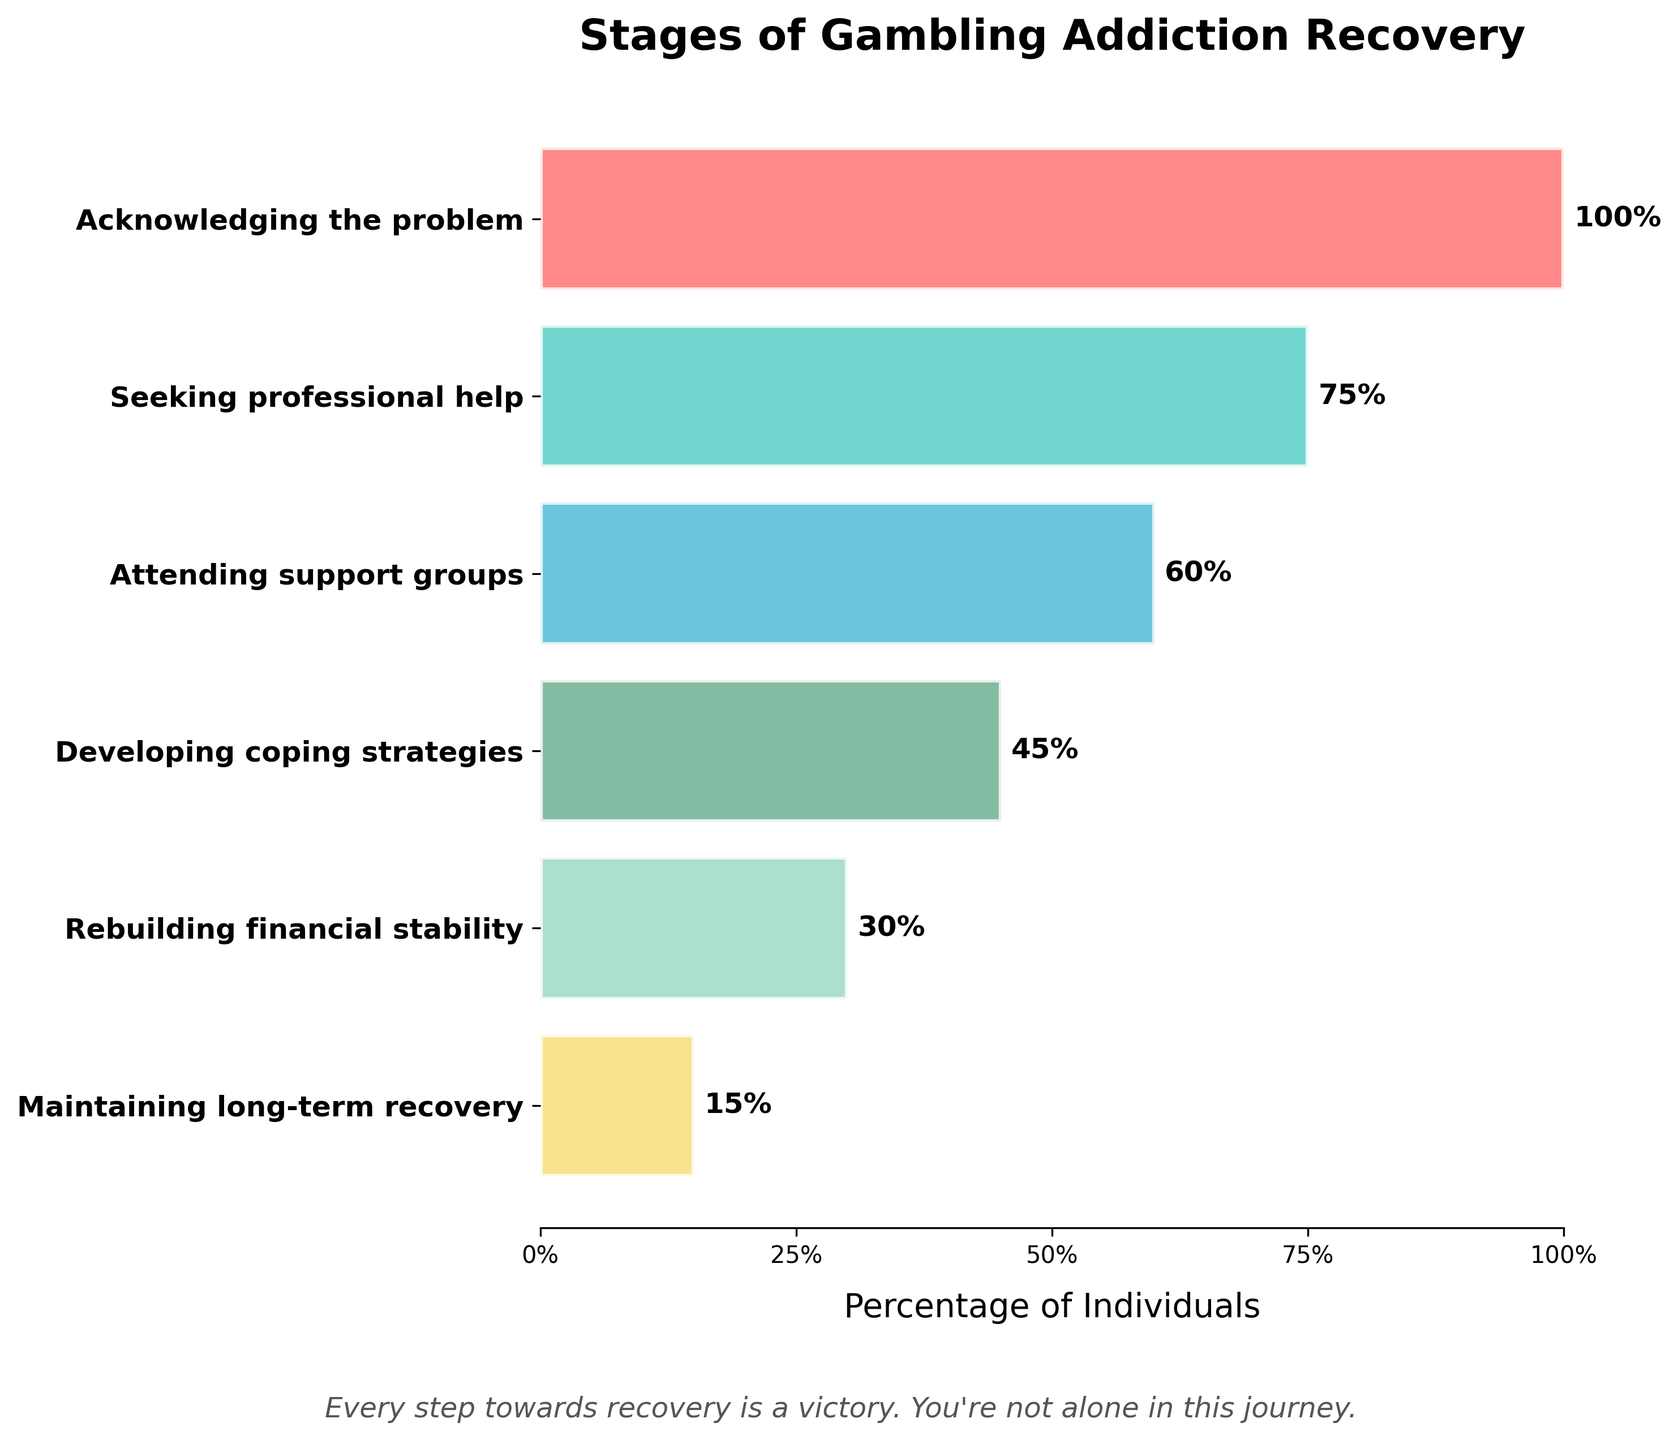What is the title of the funnel chart? The title is written at the top of the chart, above the graphical elements.
Answer: "Stages of Gambling Addiction Recovery" What is the percentage of individuals who attend support groups? Look for the stage labeled "Attending support groups" and find the corresponding percentage shown next to the horizontal bar.
Answer: 60% Which stage has the lowest percentage of individuals? Identify the stage with the shortest horizontal bar and the smallest percentage.
Answer: "Maintaining long-term recovery" How many stages are shown in the funnel chart? Count the number of horizontal bars, each representing a different stage.
Answer: Six stages What is the difference in percentage between those seeking professional help and rebuilding financial stability? Subtract the percentage for "Rebuilding financial stability" from the percentage for "Seeking professional help". 75% - 30% = 45%
Answer: 45% Which stage shows a 45% reduction compared to the previous stage? Identify which stage's percentage is reduced by 45% compared to the stage immediately before it. Look at the differences between each stage's percentage.
Answer: "Developing coping strategies" How does the percentage of individuals attending support groups compare to those seeking professional help? Compare the bars and percentages of "Attending support groups" and "Seeking professional help".
Answer: There are 15% fewer attending support groups than seeking professional help What is the midpoint value between the highest and lowest percentages? Calculate the midpoint value by adding the highest percentage (100%) and the lowest percentage (15%) and then dividing by 2. (100% + 15%) / 2 = 57.5%
Answer: 57.5% Which stages show a difference of more than 30% between them? Compute the differences between consecutive or non-consecutive stages and identify pairs with differences larger than 30%.
Answer: "Acknowledging the problem" and "Rebuilding financial stability" (difference: 100% - 30% = 70%); "Seeking professional help" and "Maintaining long-term recovery" (difference: 75% - 15% = 60%) What message is included at the bottom of the funnel chart? Read the supportive message placed at the bottom part of the chart.
Answer: "Every step towards recovery is a victory. You're not alone in this journey." 